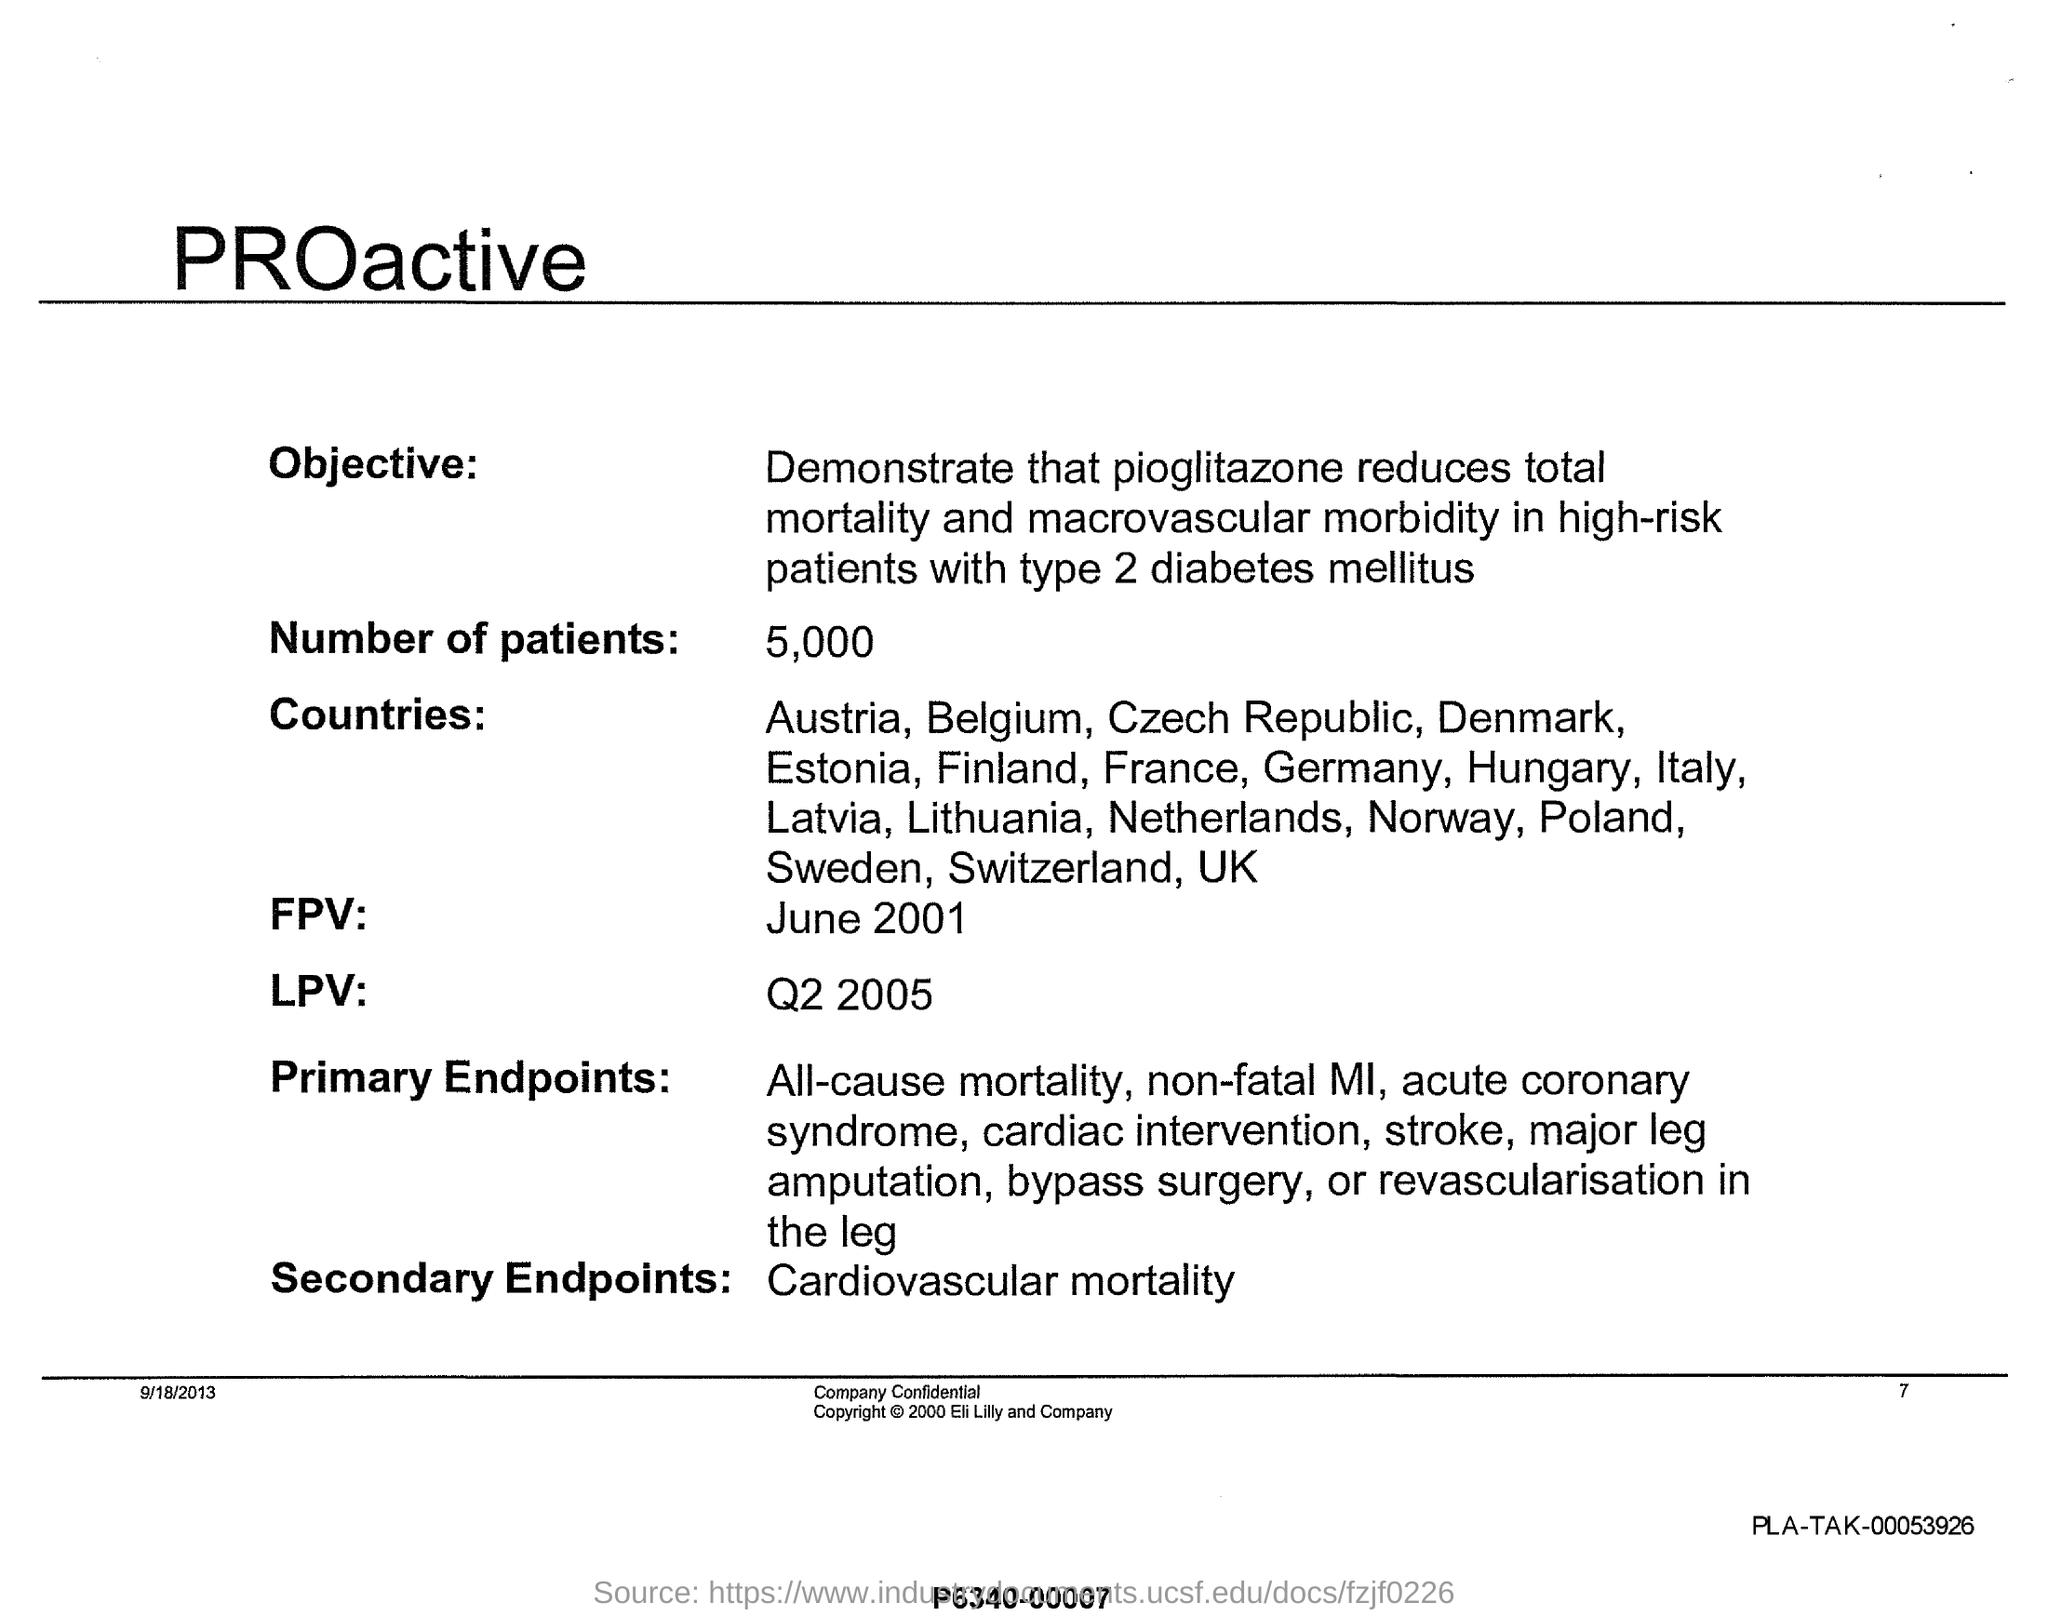What are secondary endpoints ?
Give a very brief answer. CARDIOVASCULAR MORTALITY. What is  the number of patients ?
Ensure brevity in your answer.  5,000. What is  "FPV" ?
Your response must be concise. June 2001. 